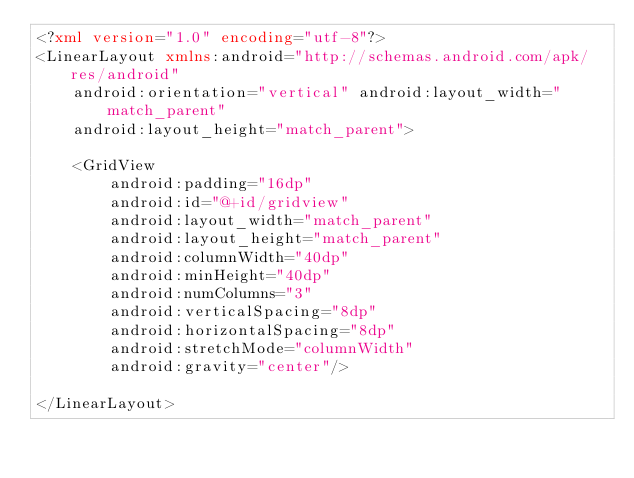<code> <loc_0><loc_0><loc_500><loc_500><_XML_><?xml version="1.0" encoding="utf-8"?>
<LinearLayout xmlns:android="http://schemas.android.com/apk/res/android"
    android:orientation="vertical" android:layout_width="match_parent"
    android:layout_height="match_parent">

    <GridView
        android:padding="16dp"
        android:id="@+id/gridview"
        android:layout_width="match_parent"
        android:layout_height="match_parent"
        android:columnWidth="40dp"
        android:minHeight="40dp"
        android:numColumns="3"
        android:verticalSpacing="8dp"
        android:horizontalSpacing="8dp"
        android:stretchMode="columnWidth"
        android:gravity="center"/>

</LinearLayout></code> 